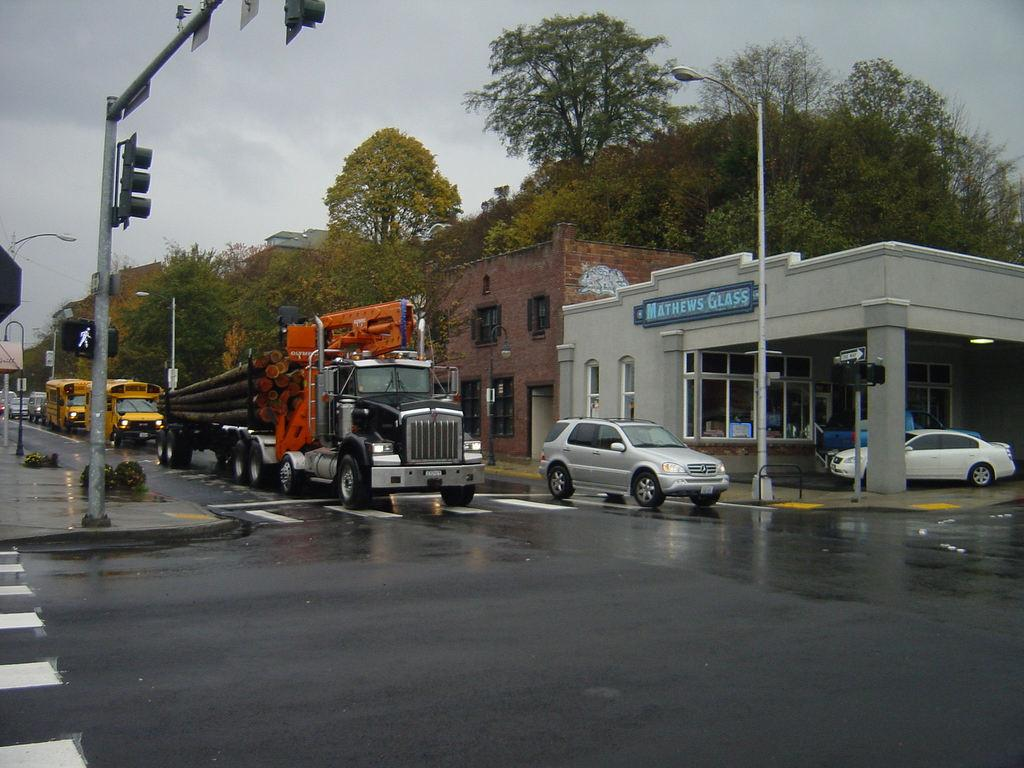What type of natural elements can be seen in the image? There are trees in the image. What type of man-made structures are present in the image? There are vehicles, traffic lights, street lights, and buildings in the image. What other objects can be seen on the ground in the image? There are other objects on the ground in the image. What is visible in the background of the image? The sky is visible in the background of the image. Can you see a goose with a wound in the image? There is no goose or wound present in the image. Is the image set during the night? The image does not provide any information about the time of day, so it cannot be determined if it is set during the night. 